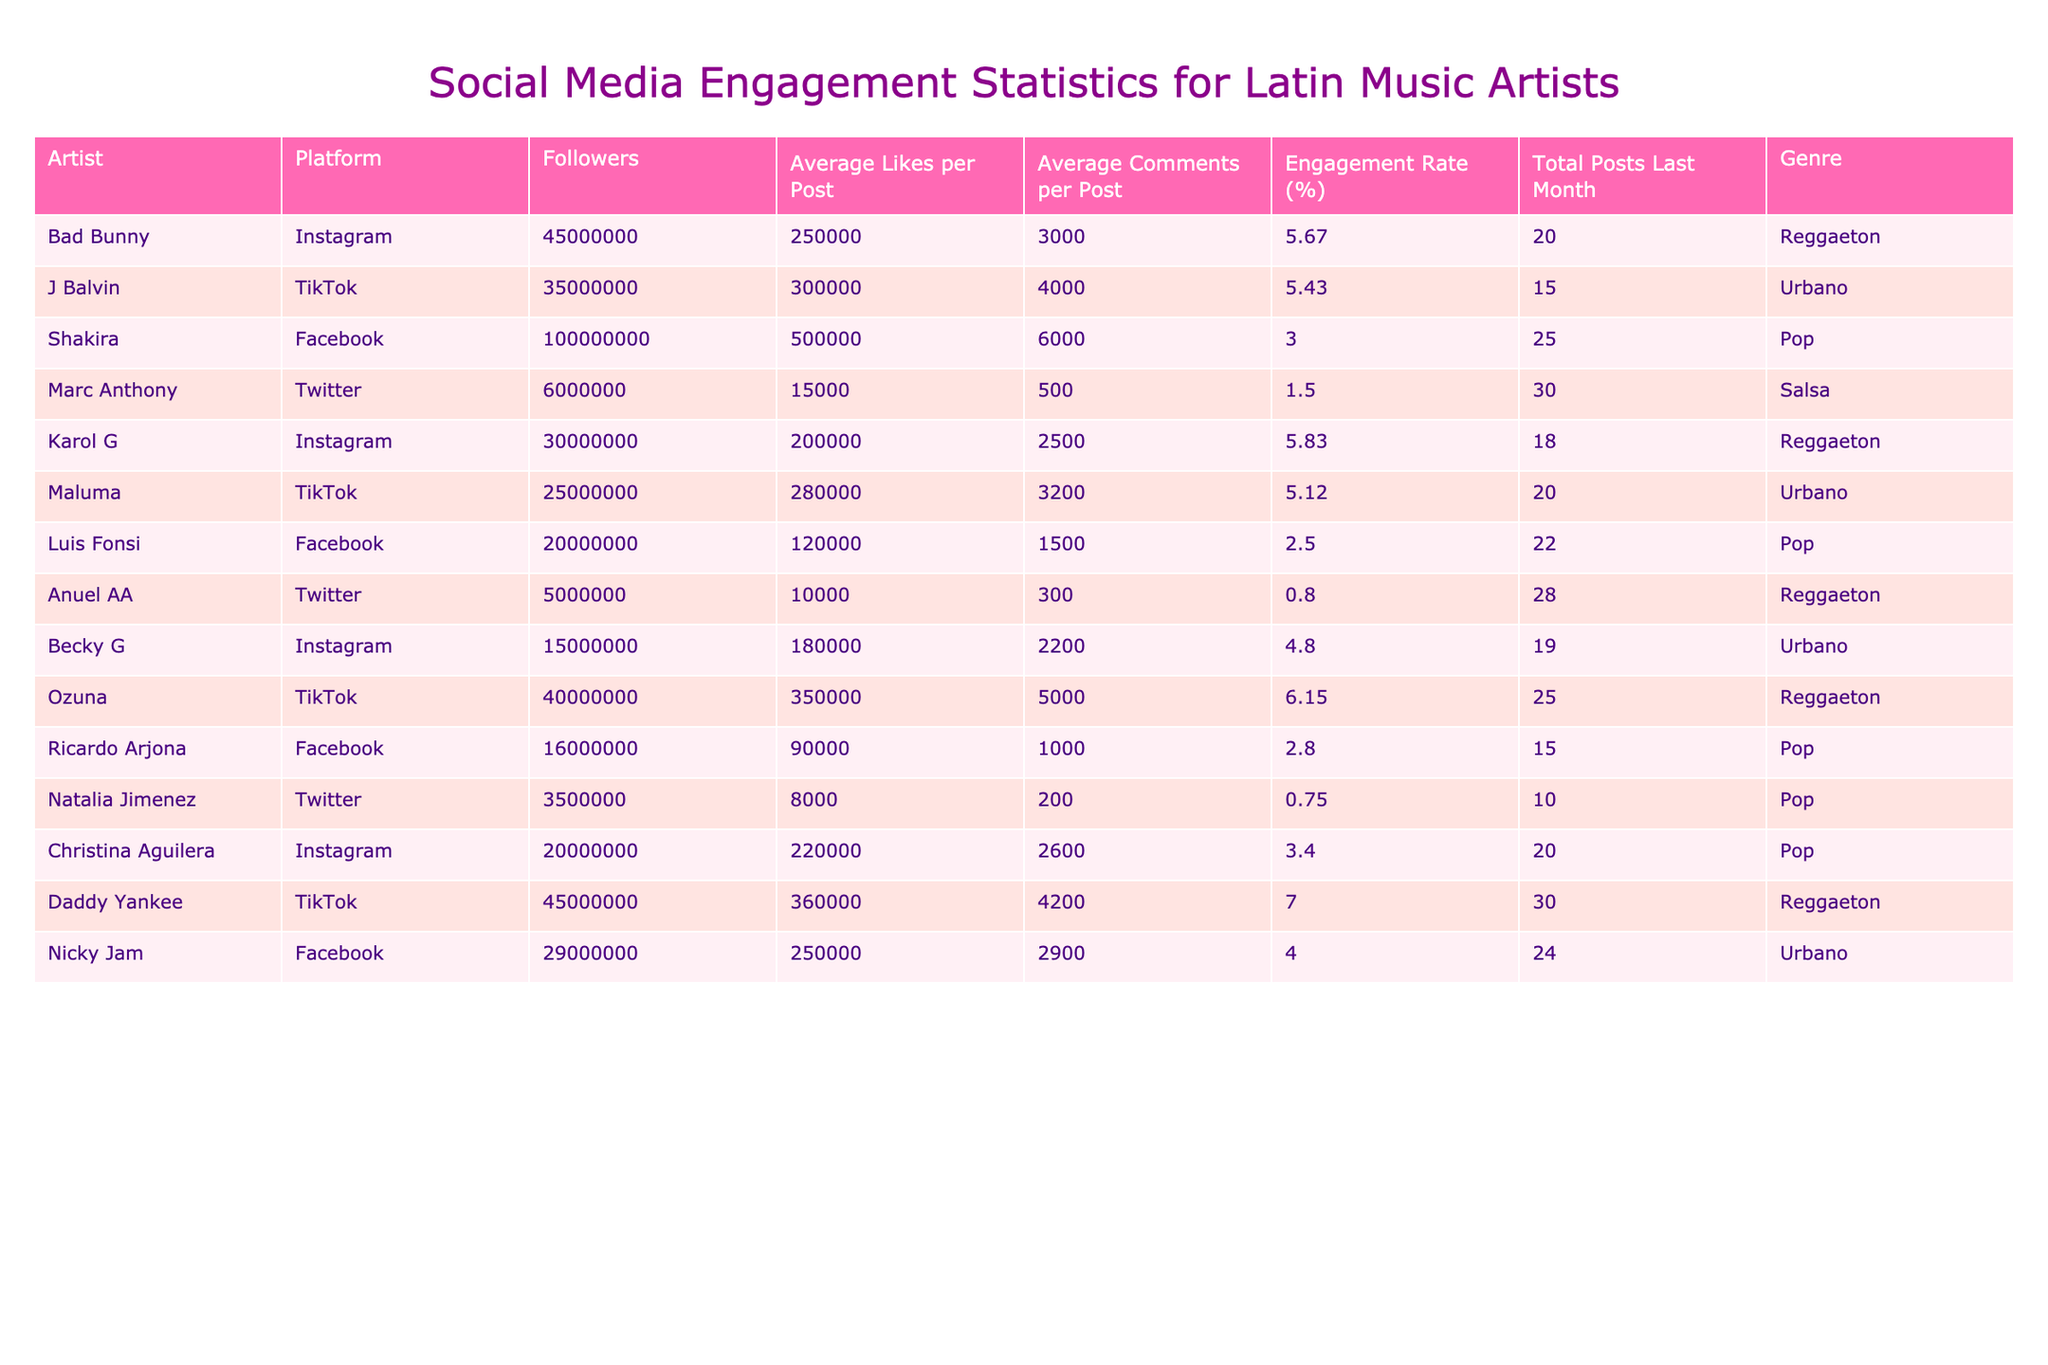What is the engagement rate of Shakira on Facebook? The engagement rate for Shakira is listed in the table and is found in the 'Engagement Rate (%)' column next to her name under Facebook, which shows 3.00%.
Answer: 3.00% Which artist has the highest number of followers on Instagram? By looking at the 'Followers' column under the 'Instagram' platform, Bad Bunny has the highest number with 45,000,000 followers.
Answer: Bad Bunny What is the average likes per post for Latin music artists on TikTok? First, we identify the artists on TikTok: J Balvin, Maluma, Ozuna, and Daddy Yankee. The likes per post are 300,000, 280,000, 350,000, and 360,000 respectively. Adding these gives 1,290,000. There are 4 artists, so we divide by 4: 1,290,000 / 4 = 322,500.
Answer: 322,500 Who has the lowest engagement rate among all artists on Twitter? We look at the engagement rates for the artists on Twitter: Marc Anthony has 1.50%, Anuel AA has 0.80%, and Natalia Jimenez has 0.75%. The lowest among these is 0.75%, which belongs to Natalia Jimenez.
Answer: Natalia Jimenez How many total posts did Daddy Yankee make last month on TikTok? The 'Total Posts Last Month' column next to Daddy Yankee's name under TikTok indicates he made 30 posts last month.
Answer: 30 Is the average comments per post for Ozuna greater than that of Karol G? Ozuna has an average of 5,000 comments per post and Karol G has 2,500. Since 5,000 is greater than 2,500, the answer is yes.
Answer: Yes What is the combined engagement rate of the top three artists with the highest engagement from the table? The top three artists with the highest engagement rates are Daddy Yankee (7.00%), Ozuna (6.15%), and Karol G (5.83%). Adding these gives 18.98%. To get the average, divide by 3: 18.98 / 3 = 6.3267.
Answer: 6.33 Which genre has the highest total number of followers across all platforms? We aggregate the followers by genre: Reggaeton (45M + 30M + 40M + 5M = 120M), Urbano (35M + 25M + 15M + 29M = 104M), Pop (100M + 20M + 16M = 136M), and Salsa (6M). The highest total is for Pop with 136M.
Answer: Pop What percentage of total followers does Bad Bunny represent when compared to all artists in the table? First, calculate the total followers: 45M + 35M + 100M + 6M + 30M + 25M + 20M + 5M + 15M + 40M + 6M + 3.5M + 16M = 395.5M. Bad Bunny has 45M, so (45 / 395.5) * 100 = 11.37%.
Answer: 11.37% Which artist has the most average comments per post in the Urbano genre? In the Urbano genre, the average comments are: J Balvin (4,000), Maluma (3,200), Becky G (2,200), and Nicky Jam (2,900). The highest value is 4,000 for J Balvin.
Answer: J Balvin 